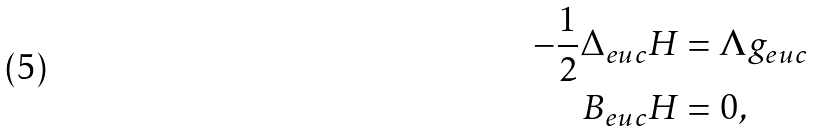<formula> <loc_0><loc_0><loc_500><loc_500>- \frac { 1 } { 2 } \Delta _ { e u c } H & = \Lambda g _ { e u c } \\ B _ { e u c } H & = 0 ,</formula> 